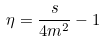Convert formula to latex. <formula><loc_0><loc_0><loc_500><loc_500>\eta = \frac { s } { 4 m ^ { 2 } } - 1</formula> 